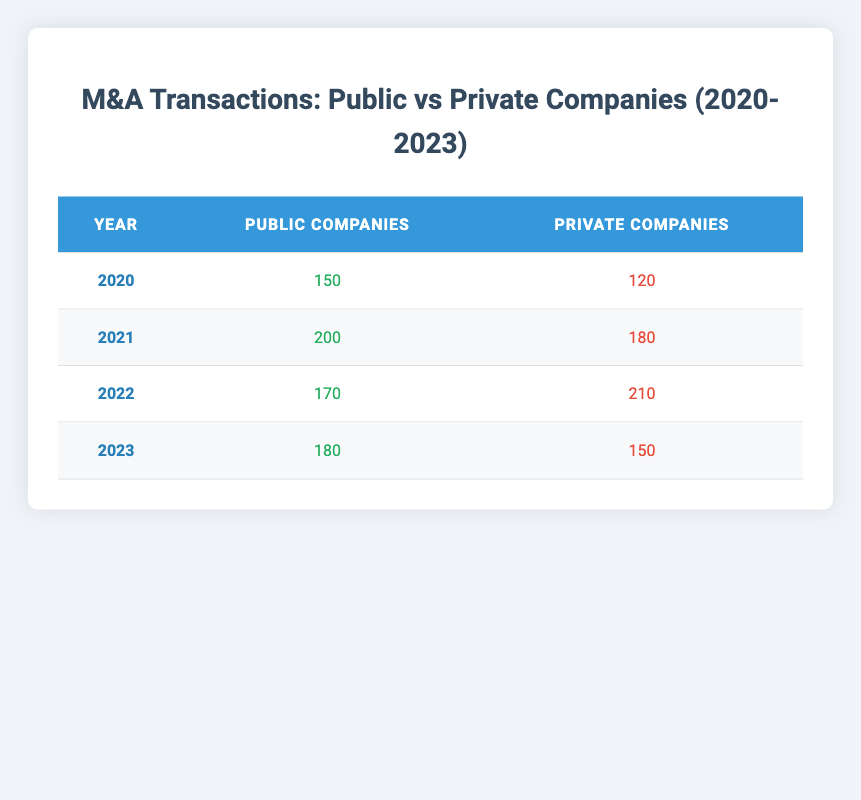What is the total number of public companies involved in M&A transactions from 2020 to 2023? To find the total number of public companies, add the values for each year: 150 (2020) + 200 (2021) + 170 (2022) + 180 (2023) = 700.
Answer: 700 In which year did the number of private companies involved in M&A transactions reach its highest point? By examining the values in the "Private Companies" column, we see that 210 (2022) is the highest value, indicating that 2022 was the peak year for private companies in M&A transactions.
Answer: 2022 What is the average number of public companies involved in M&A transactions during these four years? To find the average, sum the public companies for all years (150 + 200 + 170 + 180 = 700) and divide by the number of years (4): 700 / 4 = 175.
Answer: 175 Did the number of public companies involved in M&A transactions increase from 2020 to 2021? Comparing the numbers, public companies increased from 150 in 2020 to 200 in 2021. Therefore, the statement is true.
Answer: Yes What is the difference between the number of private companies in M&A transactions for 2021 and 2023? Subtract the number of private companies in 2023 (150) from that in 2021 (180): 180 - 150 = 30. This indicates there were more private companies involved in 2021 compared to 2023.
Answer: 30 In which year was the number of public companies the least compared to prior years? Looking at the public companies per year, 150 (2020) is the minimum when compared to 200 (2021), 170 (2022), and 180 (2023). Thus, 2020 is the year with the least number of public companies involved in M&A transactions.
Answer: 2020 Is it true that in 2022, the number of private companies was greater than the number of public companies involved in M&A transactions? In 2022, the number of private companies was 210, while public companies numbered 170. Since 210 is greater than 170, the statement is true.
Answer: Yes What was the change in the number of public companies involved in M&A transactions from 2021 to 2022? To find the change, subtract the number of public companies in 2022 (170) from that in 2021 (200): 200 - 170 = 30. This shows a decrease of 30 public companies from 2021 to 2022.
Answer: 30 